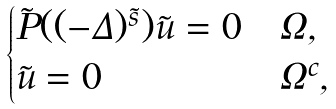<formula> <loc_0><loc_0><loc_500><loc_500>\begin{cases} \tilde { P } ( ( - \Delta ) ^ { \tilde { s } } ) \tilde { u } = 0 & \Omega , \\ \tilde { u } = 0 & \Omega ^ { c } , \end{cases}</formula> 